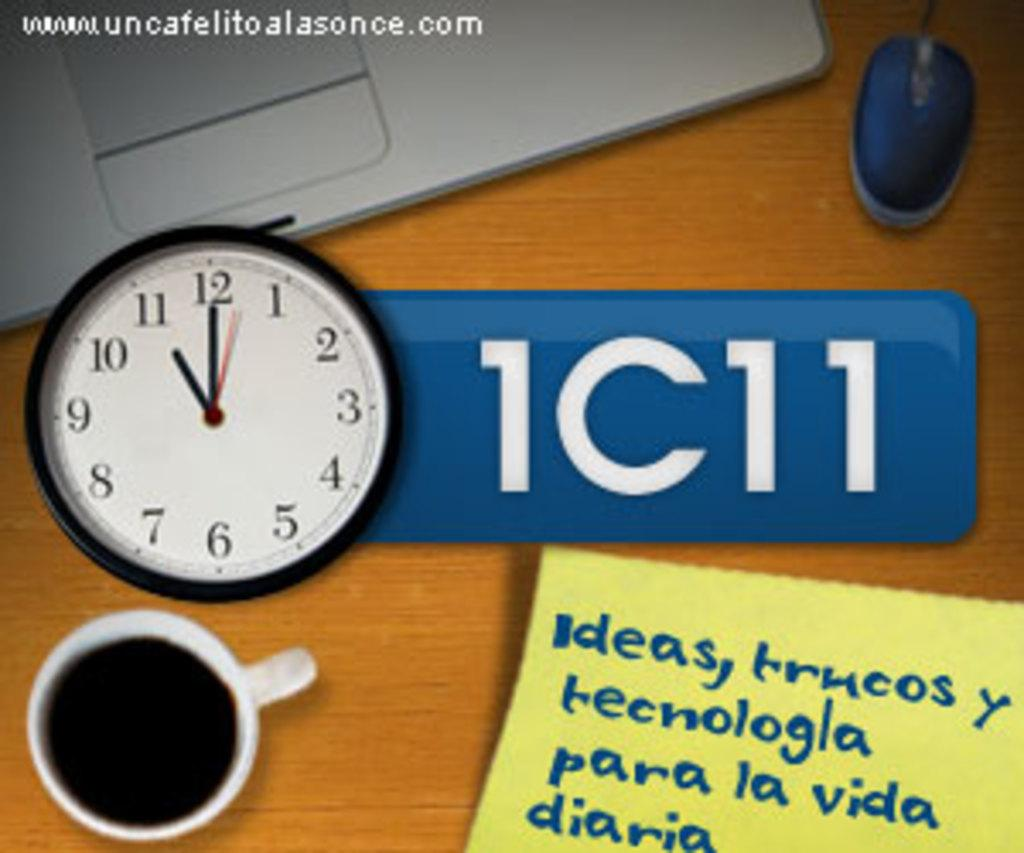<image>
Describe the image concisely. A poster talking about time and ideas in Spanish. 